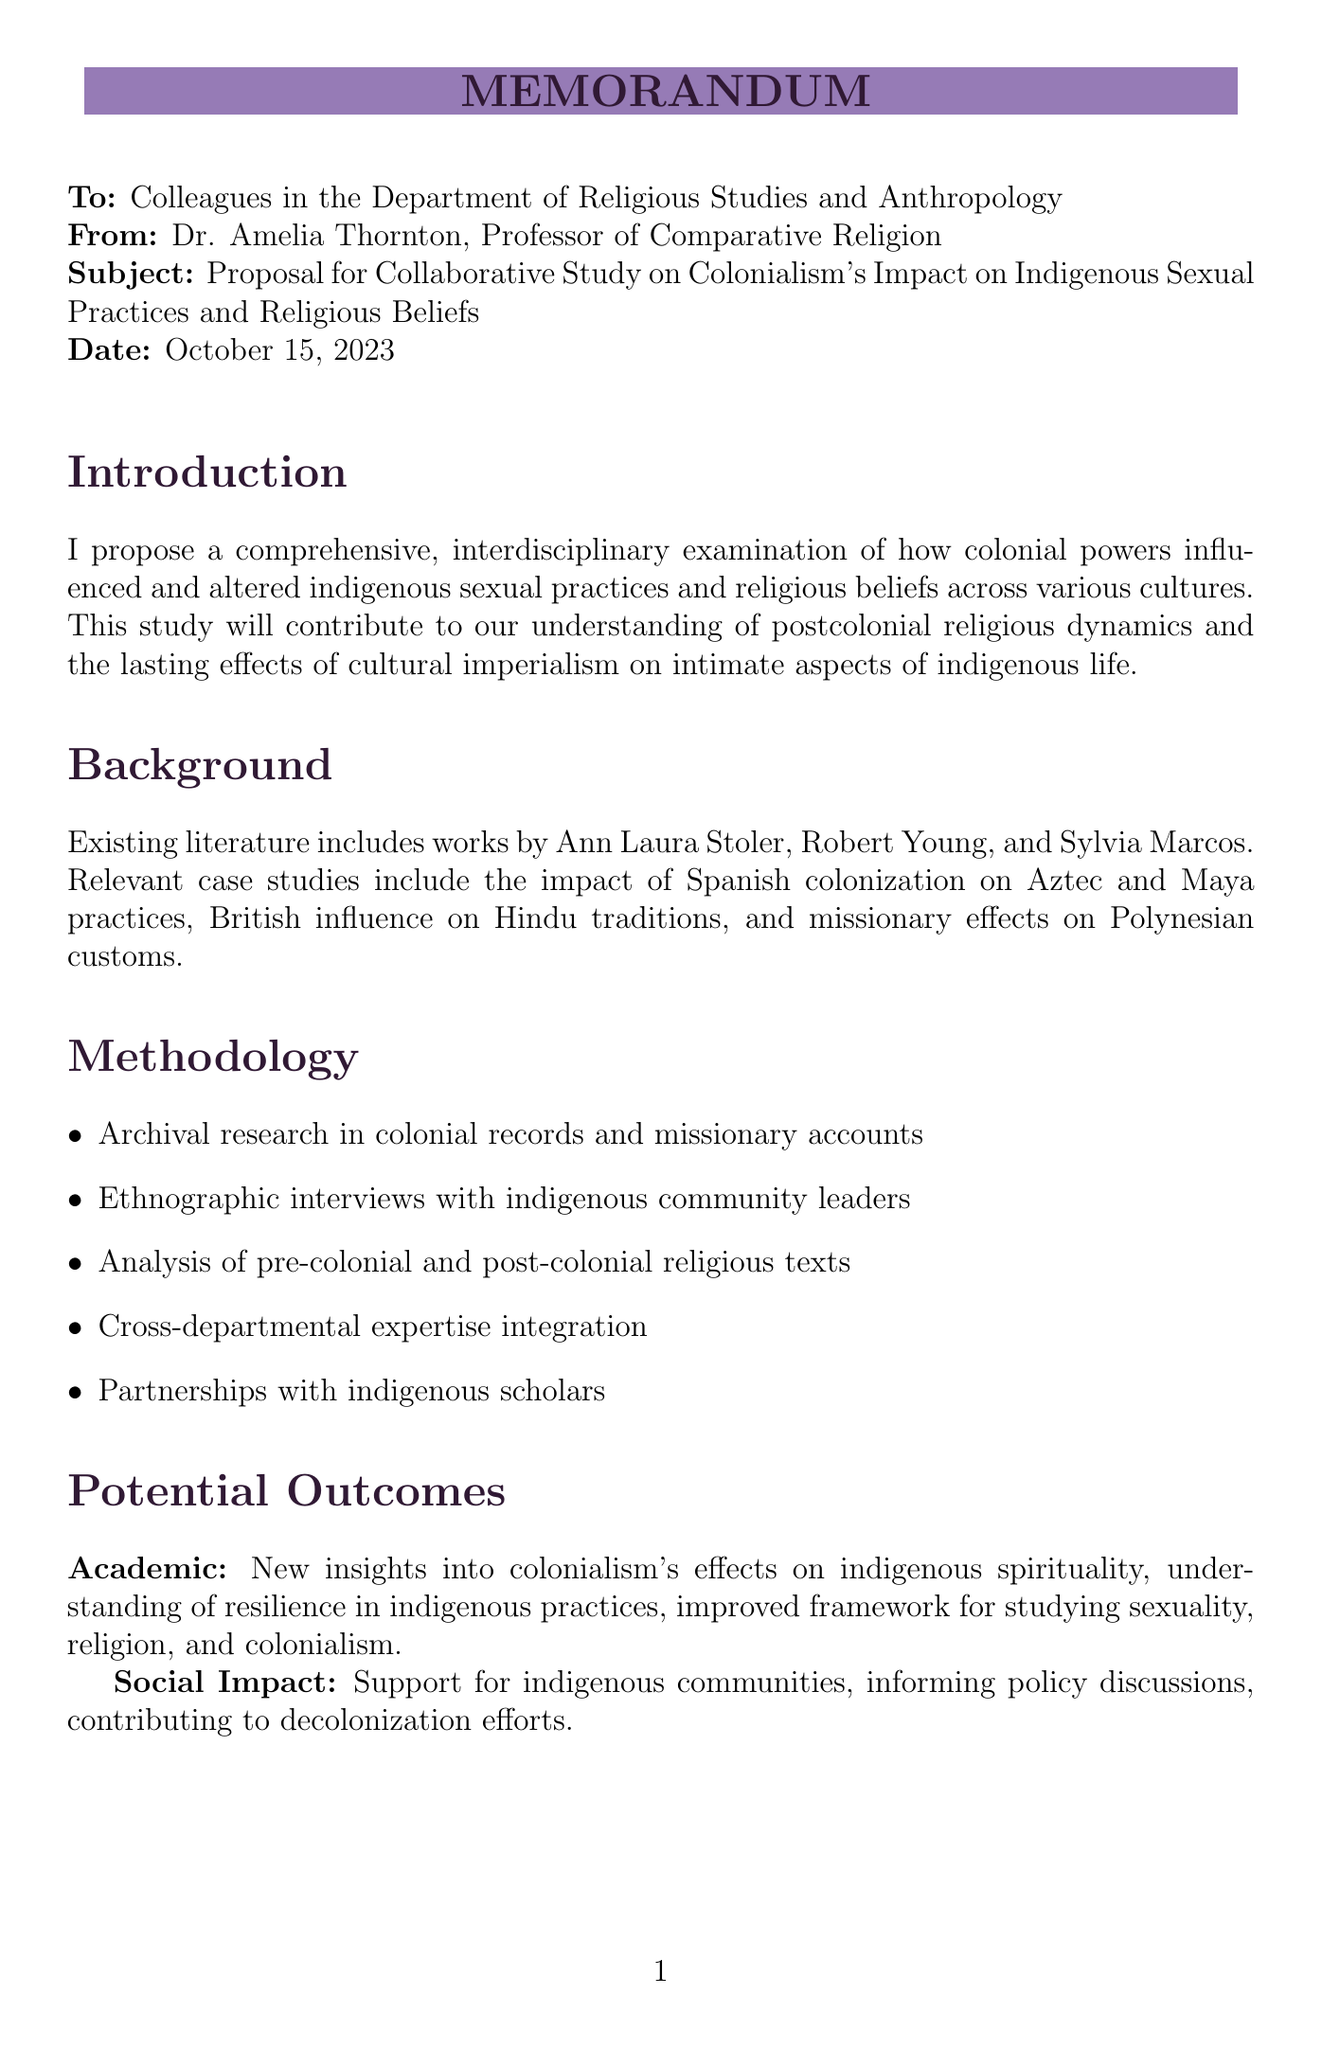What is the date of the memo? The date of the memo is stated at the top of the document under the date section.
Answer: October 15, 2023 Who is the principal investigator? The principal investigator is listed in the resource requirements section of the memo.
Answer: Dr. Amelia Thornton What is the proposed timeframe for the study? The timeframe for the study is mentioned under the resource requirements section, indicating how long the project will last.
Answer: Three-year study period What is a key aspect of the proposed methodology? The proposed methodology includes specific approaches that will be taken in the study, outlined clearly in that section.
Answer: Archival research in colonial records and missionary accounts What is one expected academic contribution of the study? The expected outcomes of the study are specified in the potential outcomes section, highlighting the academic contributions that are anticipated.
Answer: New insights into the long-term effects of colonialism on indigenous spirituality What is the purpose of establishing an Indigenous Advisory Board? The ethical considerations section discusses the importance of community engagement in the research process.
Answer: To guide research protocols Which funding program is mentioned for support? The resource requirements section details the funding sources that will be applied for to support the study.
Answer: Ford Foundation's Advancing Indigenous Rights program What is the call to action in the conclusion? The conclusion provides a summary of what the author invites colleagues to do regarding the proposal.
Answer: Join me in developing this proposal further and forming a diverse, interdisciplinary research team What is a significant area identified as understudied in contemporary scholarship? The introduction mentions a gap in current research, indicating a focus for the proposed study.
Answer: Intersection of colonialism, indigenous sexuality, and religious beliefs 